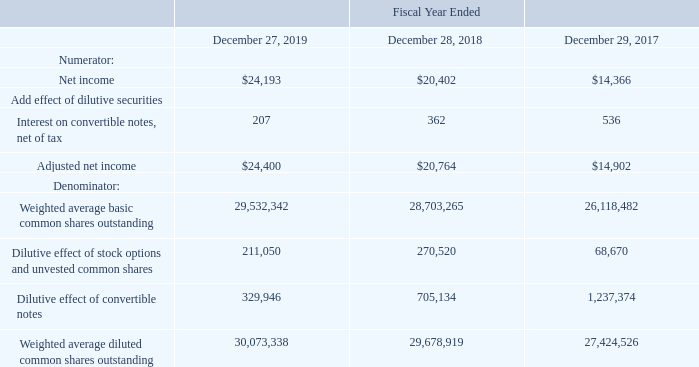Note 3 – Net Income per Share
Reconciliation of net income per common share:
What is the adjusted net income for fiscal years 2019, 2018 and 2017 respectively? $24,400, $20,764, $14,902. What is the Weighted average basic common shares outstanding for fiscal years 2019, 2018 and 2017 respectively? 29,532,342, 28,703,265, 26,118,482. What is the Weighted average diluted common shares outstanding for fiscal years 2019, 2018 and 2017 respectively? 30,073,338, 29,678,919, 27,424,526. What is the change in the adjusted net income between 2018 and 2019? 24,400-20,764
Answer: 3636. Which year has the highest adjusted net income? $24,400>$20,764>$14,902
Answer: 2019. What is the average adjusted net income from 2017-2019? (24,400+ 20,764+ 14,902)/3
Answer: 20022. 